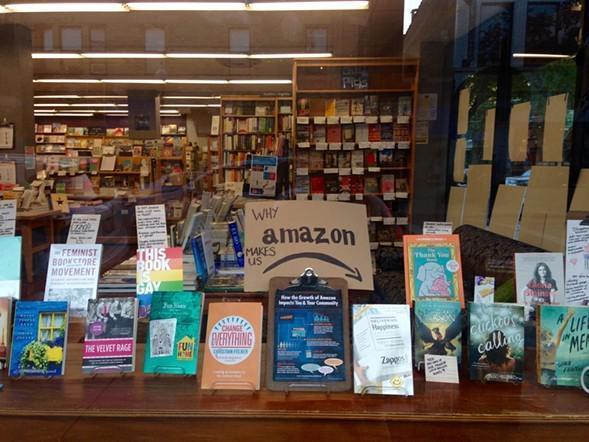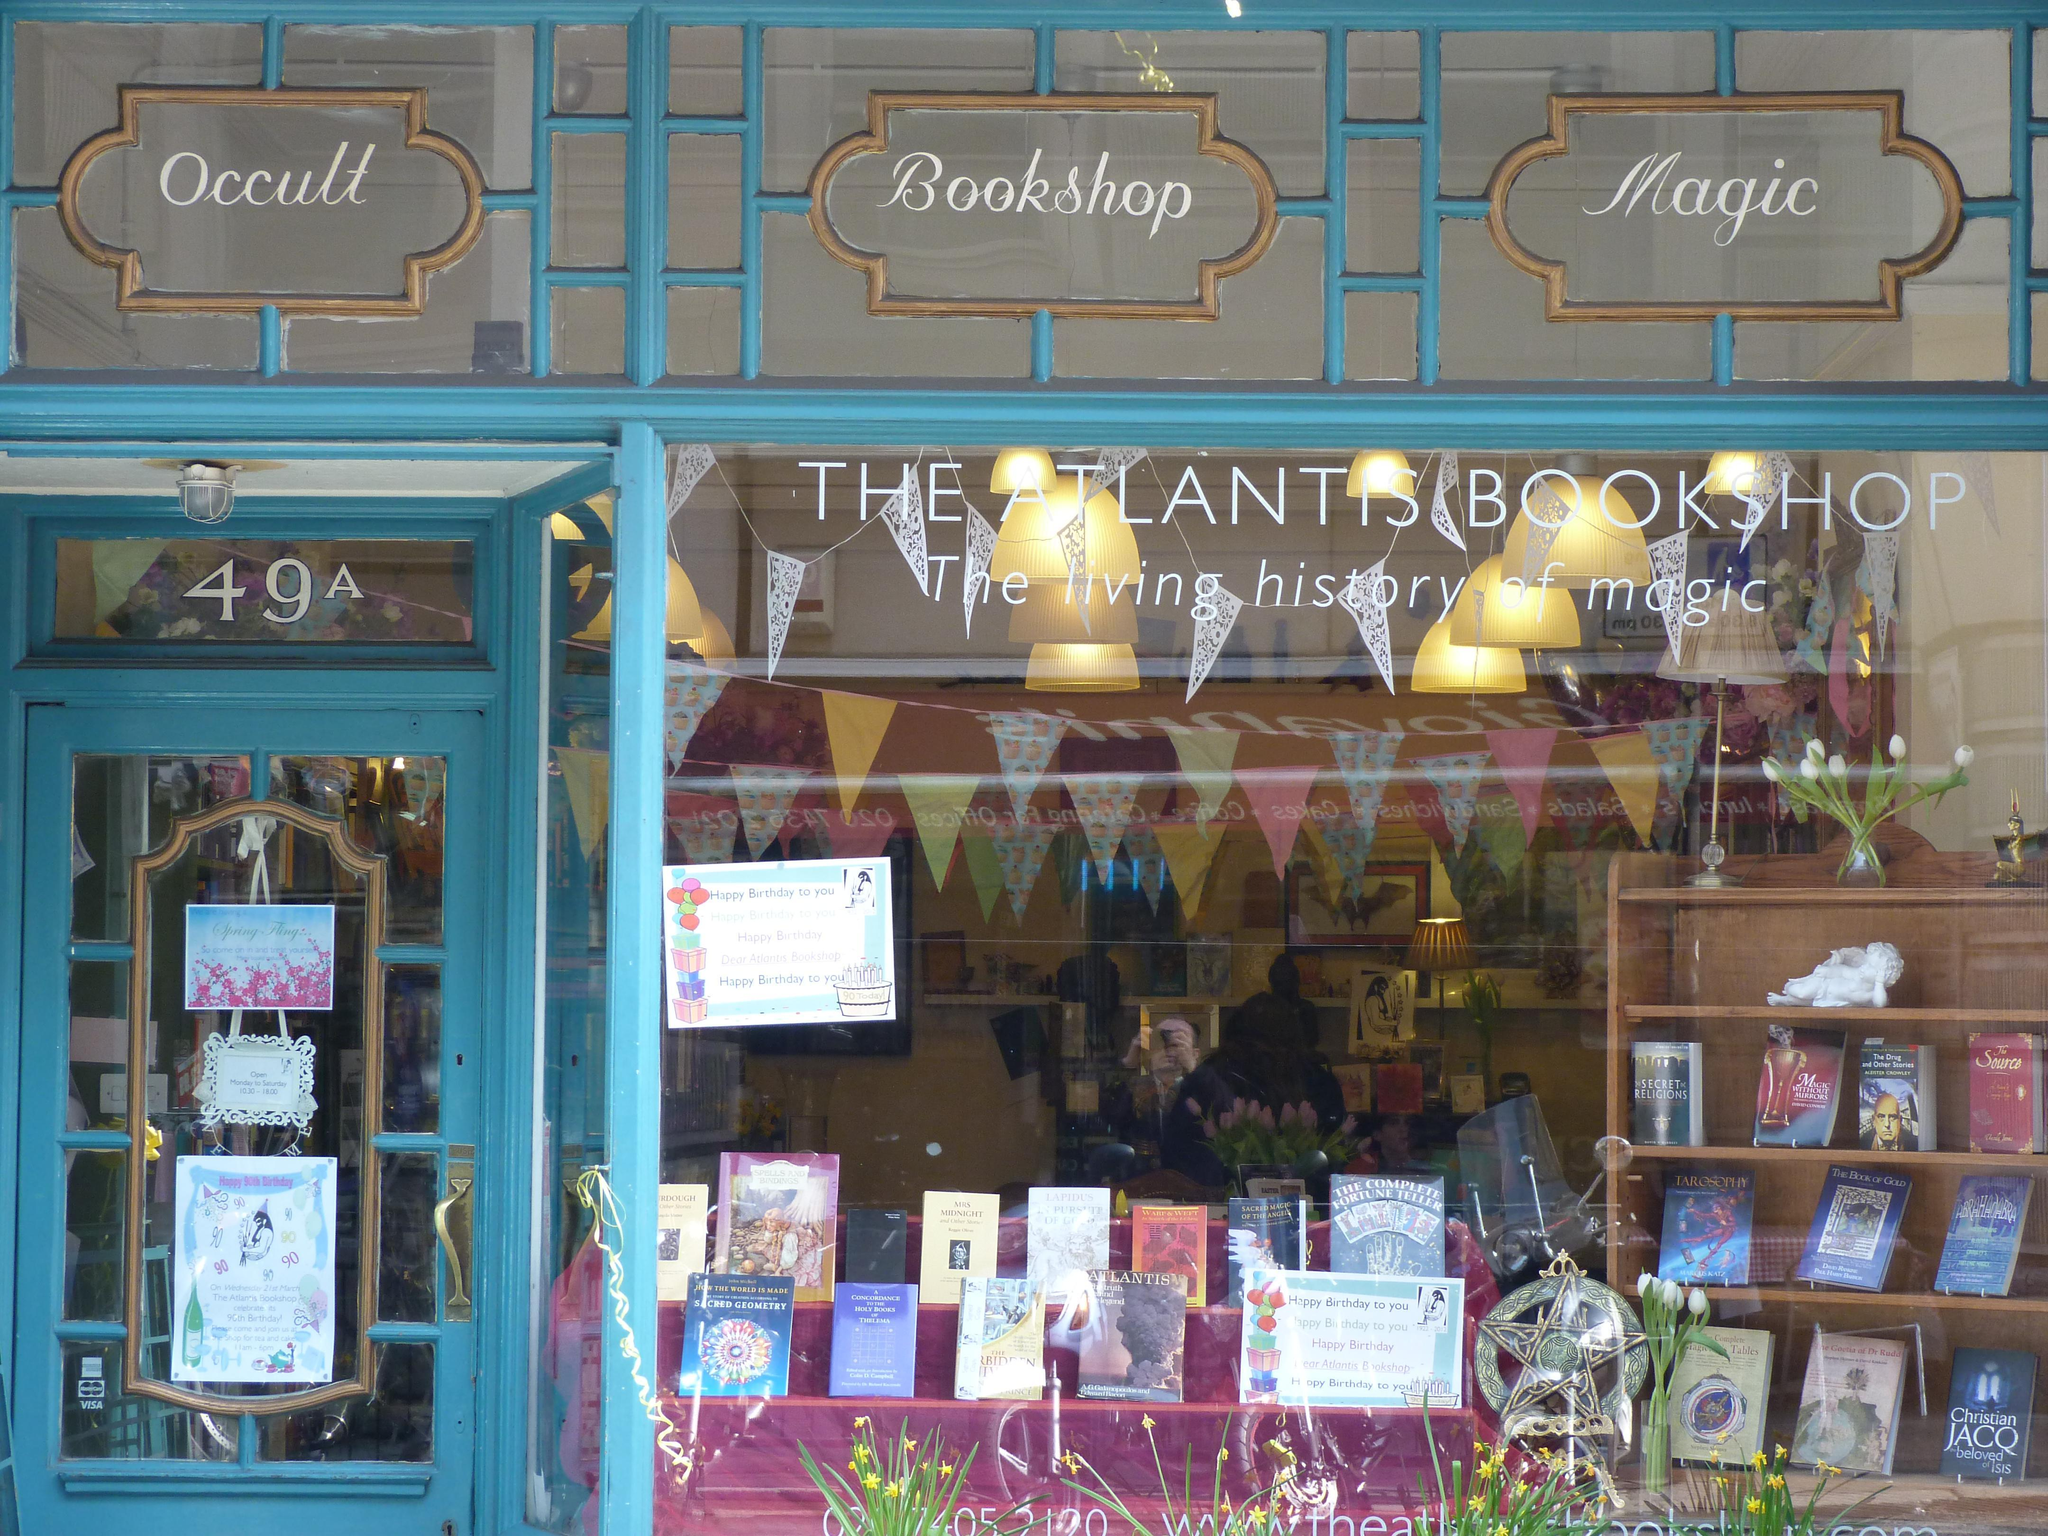The first image is the image on the left, the second image is the image on the right. For the images displayed, is the sentence "The door in the image on the right is open." factually correct? Answer yes or no. No. 